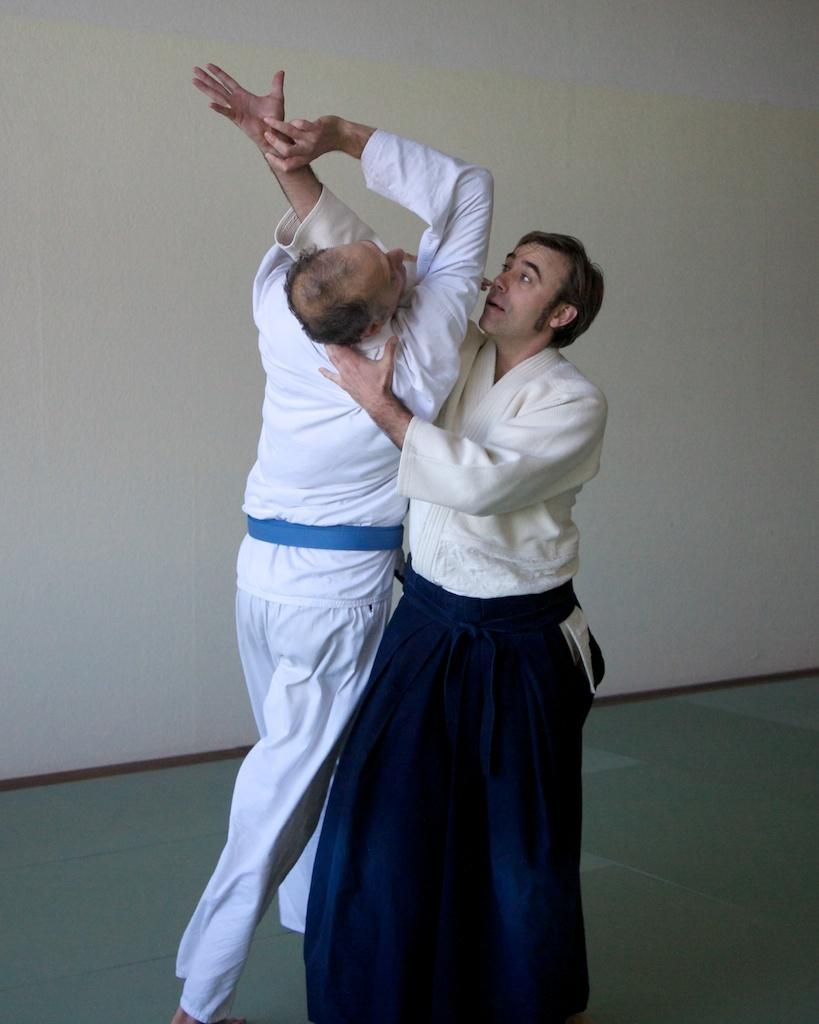How many people are in the image? There are two persons standing in the image. What is the person on the left wearing? The person on the left is wearing a white dress. What can be seen in the background of the image? The background of the image is white. What type of sponge is being used for development in the image? There is no sponge or development activity present in the image. How much snow can be seen falling in the image? There is no snow or indication of snowfall in the image. 